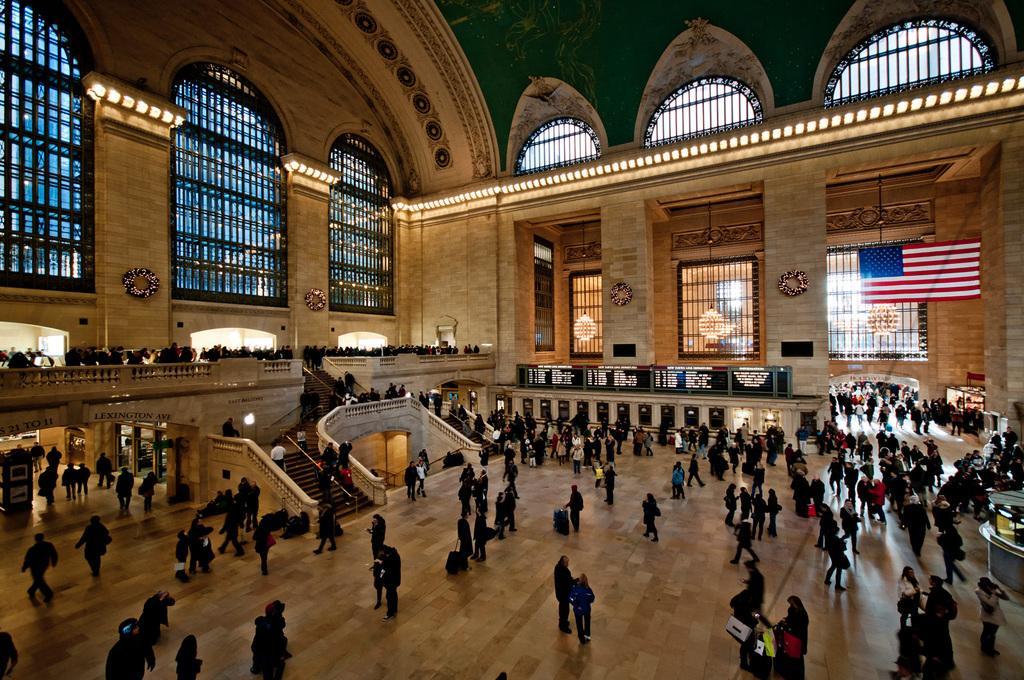How would you summarize this image in a sentence or two? In this image we can see grand central terminal and there are some persons standing, walking, holding bags in their hands. 